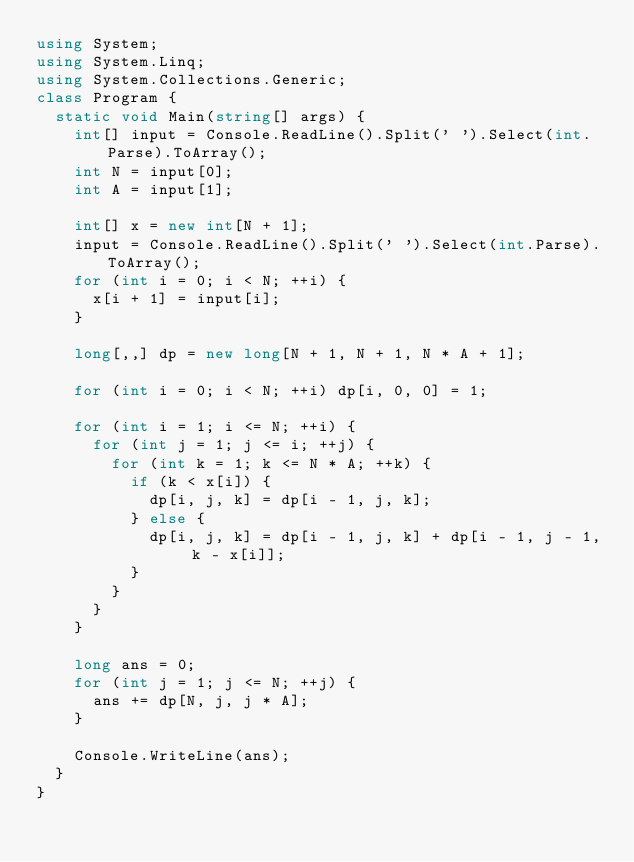Convert code to text. <code><loc_0><loc_0><loc_500><loc_500><_C#_>using System;
using System.Linq;
using System.Collections.Generic;
class Program {
  static void Main(string[] args) {
    int[] input = Console.ReadLine().Split(' ').Select(int.Parse).ToArray();
    int N = input[0];
    int A = input[1];

    int[] x = new int[N + 1];
    input = Console.ReadLine().Split(' ').Select(int.Parse).ToArray();
    for (int i = 0; i < N; ++i) {
      x[i + 1] = input[i];
    }

    long[,,] dp = new long[N + 1, N + 1, N * A + 1];

    for (int i = 0; i < N; ++i) dp[i, 0, 0] = 1;

    for (int i = 1; i <= N; ++i) {
      for (int j = 1; j <= i; ++j) {
        for (int k = 1; k <= N * A; ++k) {
          if (k < x[i]) {
            dp[i, j, k] = dp[i - 1, j, k];
          } else {
            dp[i, j, k] = dp[i - 1, j, k] + dp[i - 1, j - 1, k - x[i]];
          }
        }
      }
    }

    long ans = 0;
    for (int j = 1; j <= N; ++j) {
      ans += dp[N, j, j * A];
    }

    Console.WriteLine(ans);
  }
}
</code> 